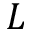<formula> <loc_0><loc_0><loc_500><loc_500>L</formula> 